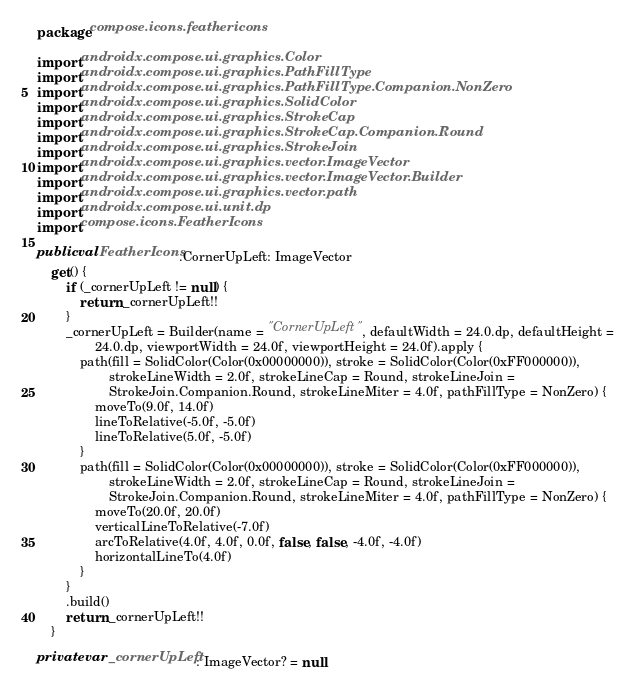Convert code to text. <code><loc_0><loc_0><loc_500><loc_500><_Kotlin_>package compose.icons.feathericons

import androidx.compose.ui.graphics.Color
import androidx.compose.ui.graphics.PathFillType
import androidx.compose.ui.graphics.PathFillType.Companion.NonZero
import androidx.compose.ui.graphics.SolidColor
import androidx.compose.ui.graphics.StrokeCap
import androidx.compose.ui.graphics.StrokeCap.Companion.Round
import androidx.compose.ui.graphics.StrokeJoin
import androidx.compose.ui.graphics.vector.ImageVector
import androidx.compose.ui.graphics.vector.ImageVector.Builder
import androidx.compose.ui.graphics.vector.path
import androidx.compose.ui.unit.dp
import compose.icons.FeatherIcons

public val FeatherIcons.CornerUpLeft: ImageVector
    get() {
        if (_cornerUpLeft != null) {
            return _cornerUpLeft!!
        }
        _cornerUpLeft = Builder(name = "CornerUpLeft", defaultWidth = 24.0.dp, defaultHeight =
                24.0.dp, viewportWidth = 24.0f, viewportHeight = 24.0f).apply {
            path(fill = SolidColor(Color(0x00000000)), stroke = SolidColor(Color(0xFF000000)),
                    strokeLineWidth = 2.0f, strokeLineCap = Round, strokeLineJoin =
                    StrokeJoin.Companion.Round, strokeLineMiter = 4.0f, pathFillType = NonZero) {
                moveTo(9.0f, 14.0f)
                lineToRelative(-5.0f, -5.0f)
                lineToRelative(5.0f, -5.0f)
            }
            path(fill = SolidColor(Color(0x00000000)), stroke = SolidColor(Color(0xFF000000)),
                    strokeLineWidth = 2.0f, strokeLineCap = Round, strokeLineJoin =
                    StrokeJoin.Companion.Round, strokeLineMiter = 4.0f, pathFillType = NonZero) {
                moveTo(20.0f, 20.0f)
                verticalLineToRelative(-7.0f)
                arcToRelative(4.0f, 4.0f, 0.0f, false, false, -4.0f, -4.0f)
                horizontalLineTo(4.0f)
            }
        }
        .build()
        return _cornerUpLeft!!
    }

private var _cornerUpLeft: ImageVector? = null
</code> 